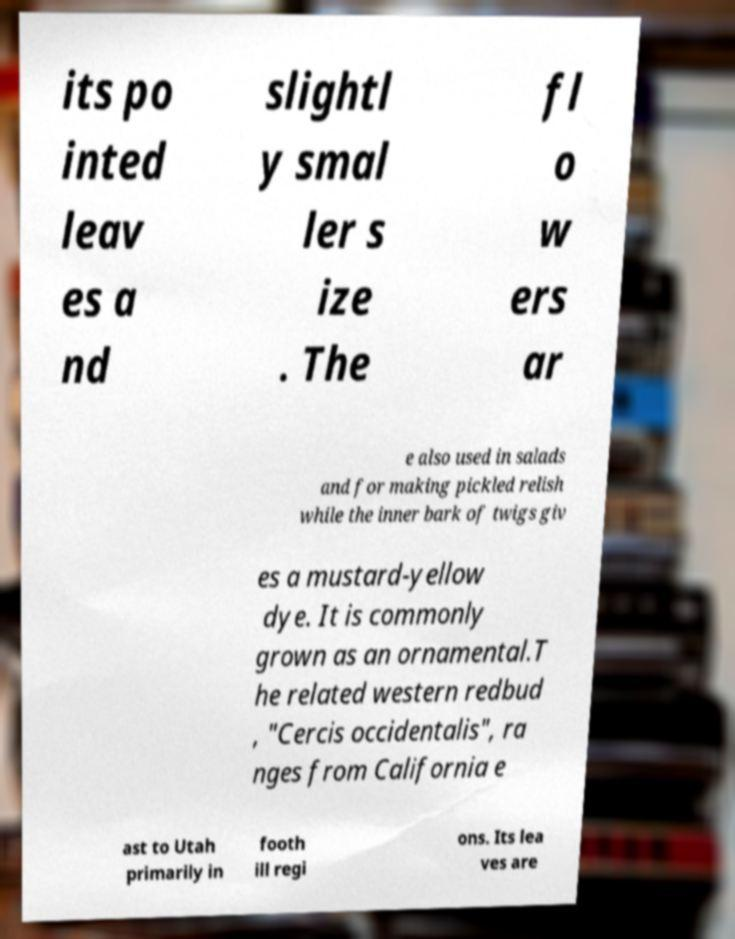There's text embedded in this image that I need extracted. Can you transcribe it verbatim? its po inted leav es a nd slightl y smal ler s ize . The fl o w ers ar e also used in salads and for making pickled relish while the inner bark of twigs giv es a mustard-yellow dye. It is commonly grown as an ornamental.T he related western redbud , "Cercis occidentalis", ra nges from California e ast to Utah primarily in footh ill regi ons. Its lea ves are 